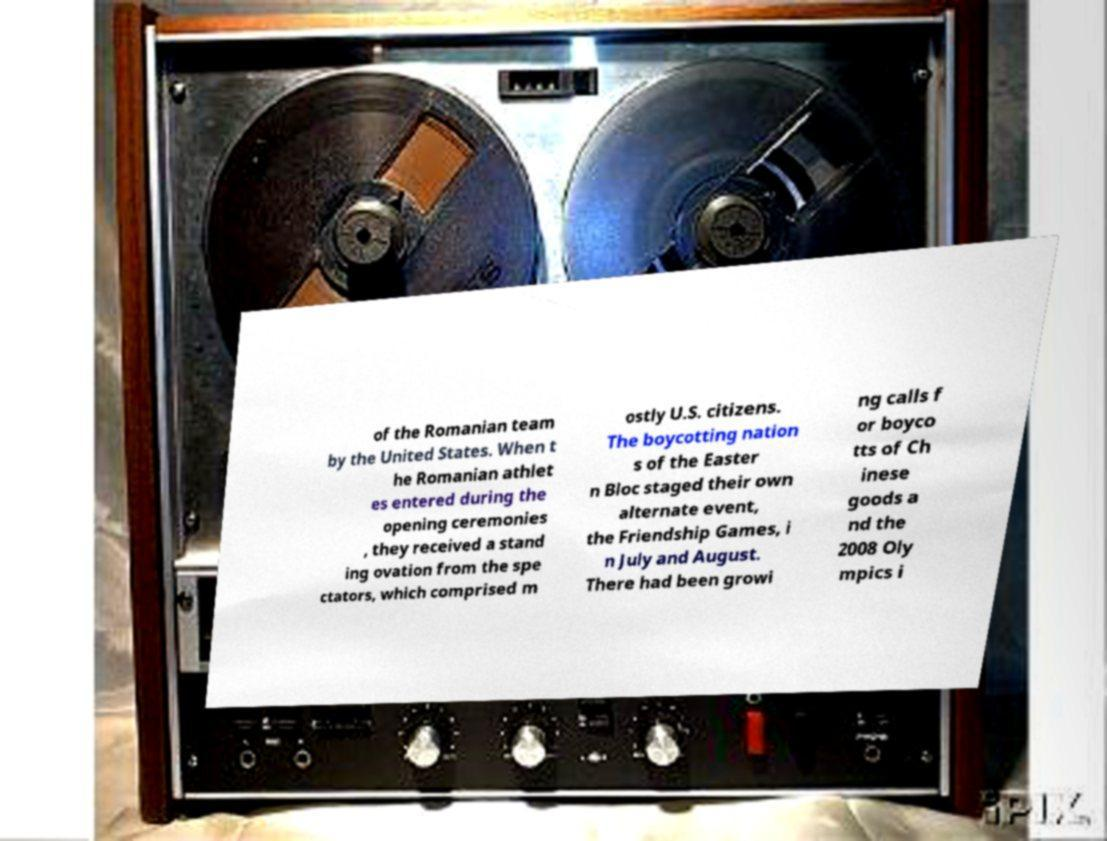Can you accurately transcribe the text from the provided image for me? of the Romanian team by the United States. When t he Romanian athlet es entered during the opening ceremonies , they received a stand ing ovation from the spe ctators, which comprised m ostly U.S. citizens. The boycotting nation s of the Easter n Bloc staged their own alternate event, the Friendship Games, i n July and August. There had been growi ng calls f or boyco tts of Ch inese goods a nd the 2008 Oly mpics i 